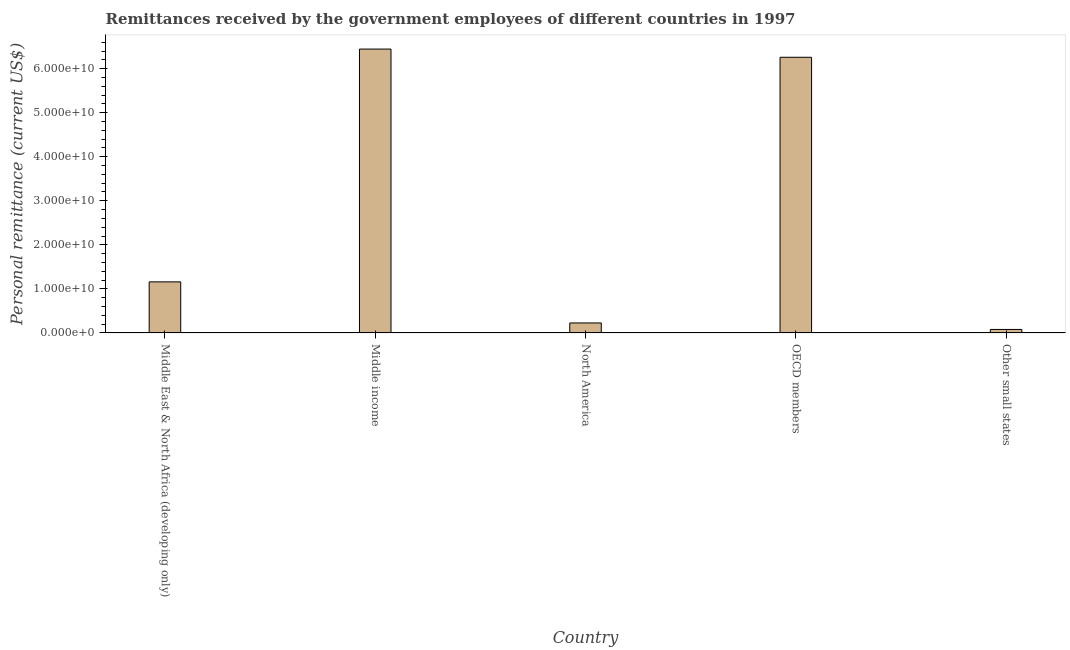Does the graph contain grids?
Keep it short and to the point. No. What is the title of the graph?
Make the answer very short. Remittances received by the government employees of different countries in 1997. What is the label or title of the Y-axis?
Offer a very short reply. Personal remittance (current US$). What is the personal remittances in OECD members?
Your answer should be very brief. 6.26e+1. Across all countries, what is the maximum personal remittances?
Make the answer very short. 6.44e+1. Across all countries, what is the minimum personal remittances?
Your answer should be compact. 7.92e+08. In which country was the personal remittances maximum?
Make the answer very short. Middle income. In which country was the personal remittances minimum?
Keep it short and to the point. Other small states. What is the sum of the personal remittances?
Your response must be concise. 1.42e+11. What is the difference between the personal remittances in Middle East & North Africa (developing only) and Other small states?
Keep it short and to the point. 1.08e+1. What is the average personal remittances per country?
Offer a terse response. 2.83e+1. What is the median personal remittances?
Provide a succinct answer. 1.16e+1. In how many countries, is the personal remittances greater than 2000000000 US$?
Provide a succinct answer. 4. What is the ratio of the personal remittances in Middle East & North Africa (developing only) to that in OECD members?
Provide a succinct answer. 0.18. Is the personal remittances in Middle East & North Africa (developing only) less than that in Other small states?
Give a very brief answer. No. What is the difference between the highest and the second highest personal remittances?
Provide a short and direct response. 1.86e+09. What is the difference between the highest and the lowest personal remittances?
Make the answer very short. 6.36e+1. How many countries are there in the graph?
Your answer should be very brief. 5. What is the difference between two consecutive major ticks on the Y-axis?
Keep it short and to the point. 1.00e+1. Are the values on the major ticks of Y-axis written in scientific E-notation?
Give a very brief answer. Yes. What is the Personal remittance (current US$) of Middle East & North Africa (developing only)?
Provide a short and direct response. 1.16e+1. What is the Personal remittance (current US$) in Middle income?
Provide a short and direct response. 6.44e+1. What is the Personal remittance (current US$) in North America?
Your answer should be very brief. 2.27e+09. What is the Personal remittance (current US$) of OECD members?
Provide a short and direct response. 6.26e+1. What is the Personal remittance (current US$) in Other small states?
Offer a terse response. 7.92e+08. What is the difference between the Personal remittance (current US$) in Middle East & North Africa (developing only) and Middle income?
Provide a short and direct response. -5.28e+1. What is the difference between the Personal remittance (current US$) in Middle East & North Africa (developing only) and North America?
Provide a short and direct response. 9.33e+09. What is the difference between the Personal remittance (current US$) in Middle East & North Africa (developing only) and OECD members?
Your response must be concise. -5.10e+1. What is the difference between the Personal remittance (current US$) in Middle East & North Africa (developing only) and Other small states?
Provide a succinct answer. 1.08e+1. What is the difference between the Personal remittance (current US$) in Middle income and North America?
Ensure brevity in your answer.  6.22e+1. What is the difference between the Personal remittance (current US$) in Middle income and OECD members?
Offer a very short reply. 1.86e+09. What is the difference between the Personal remittance (current US$) in Middle income and Other small states?
Offer a terse response. 6.36e+1. What is the difference between the Personal remittance (current US$) in North America and OECD members?
Make the answer very short. -6.03e+1. What is the difference between the Personal remittance (current US$) in North America and Other small states?
Give a very brief answer. 1.48e+09. What is the difference between the Personal remittance (current US$) in OECD members and Other small states?
Keep it short and to the point. 6.18e+1. What is the ratio of the Personal remittance (current US$) in Middle East & North Africa (developing only) to that in Middle income?
Your answer should be compact. 0.18. What is the ratio of the Personal remittance (current US$) in Middle East & North Africa (developing only) to that in North America?
Your response must be concise. 5.11. What is the ratio of the Personal remittance (current US$) in Middle East & North Africa (developing only) to that in OECD members?
Give a very brief answer. 0.18. What is the ratio of the Personal remittance (current US$) in Middle East & North Africa (developing only) to that in Other small states?
Your answer should be compact. 14.65. What is the ratio of the Personal remittance (current US$) in Middle income to that in North America?
Offer a very short reply. 28.39. What is the ratio of the Personal remittance (current US$) in Middle income to that in OECD members?
Offer a terse response. 1.03. What is the ratio of the Personal remittance (current US$) in Middle income to that in Other small states?
Ensure brevity in your answer.  81.41. What is the ratio of the Personal remittance (current US$) in North America to that in OECD members?
Provide a succinct answer. 0.04. What is the ratio of the Personal remittance (current US$) in North America to that in Other small states?
Offer a terse response. 2.87. What is the ratio of the Personal remittance (current US$) in OECD members to that in Other small states?
Give a very brief answer. 79.06. 